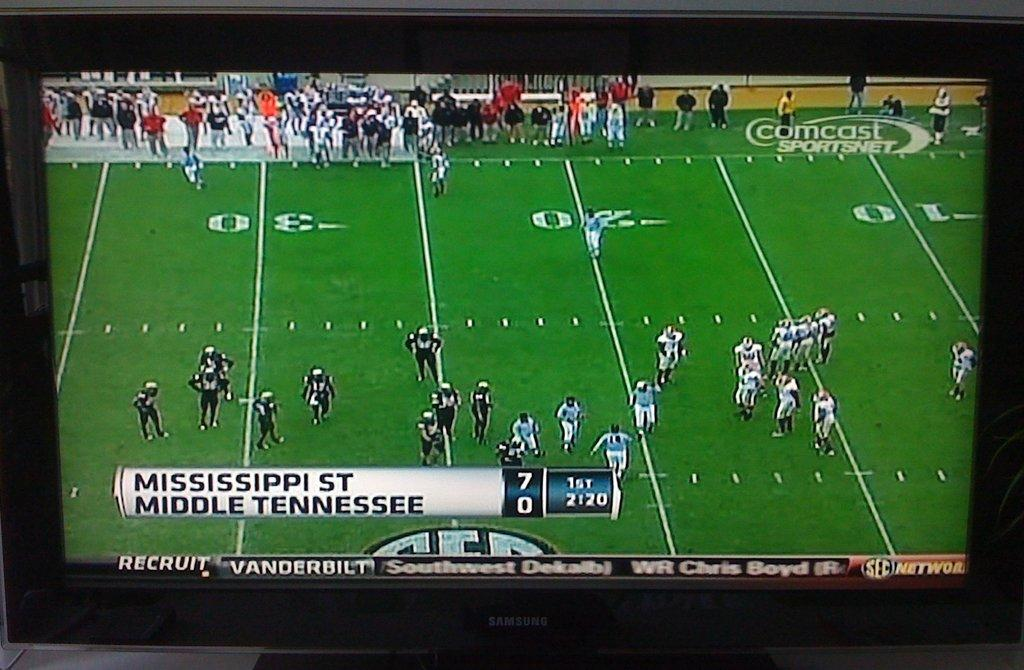<image>
Present a compact description of the photo's key features. a Mississippi St team winning by 7 against another team 